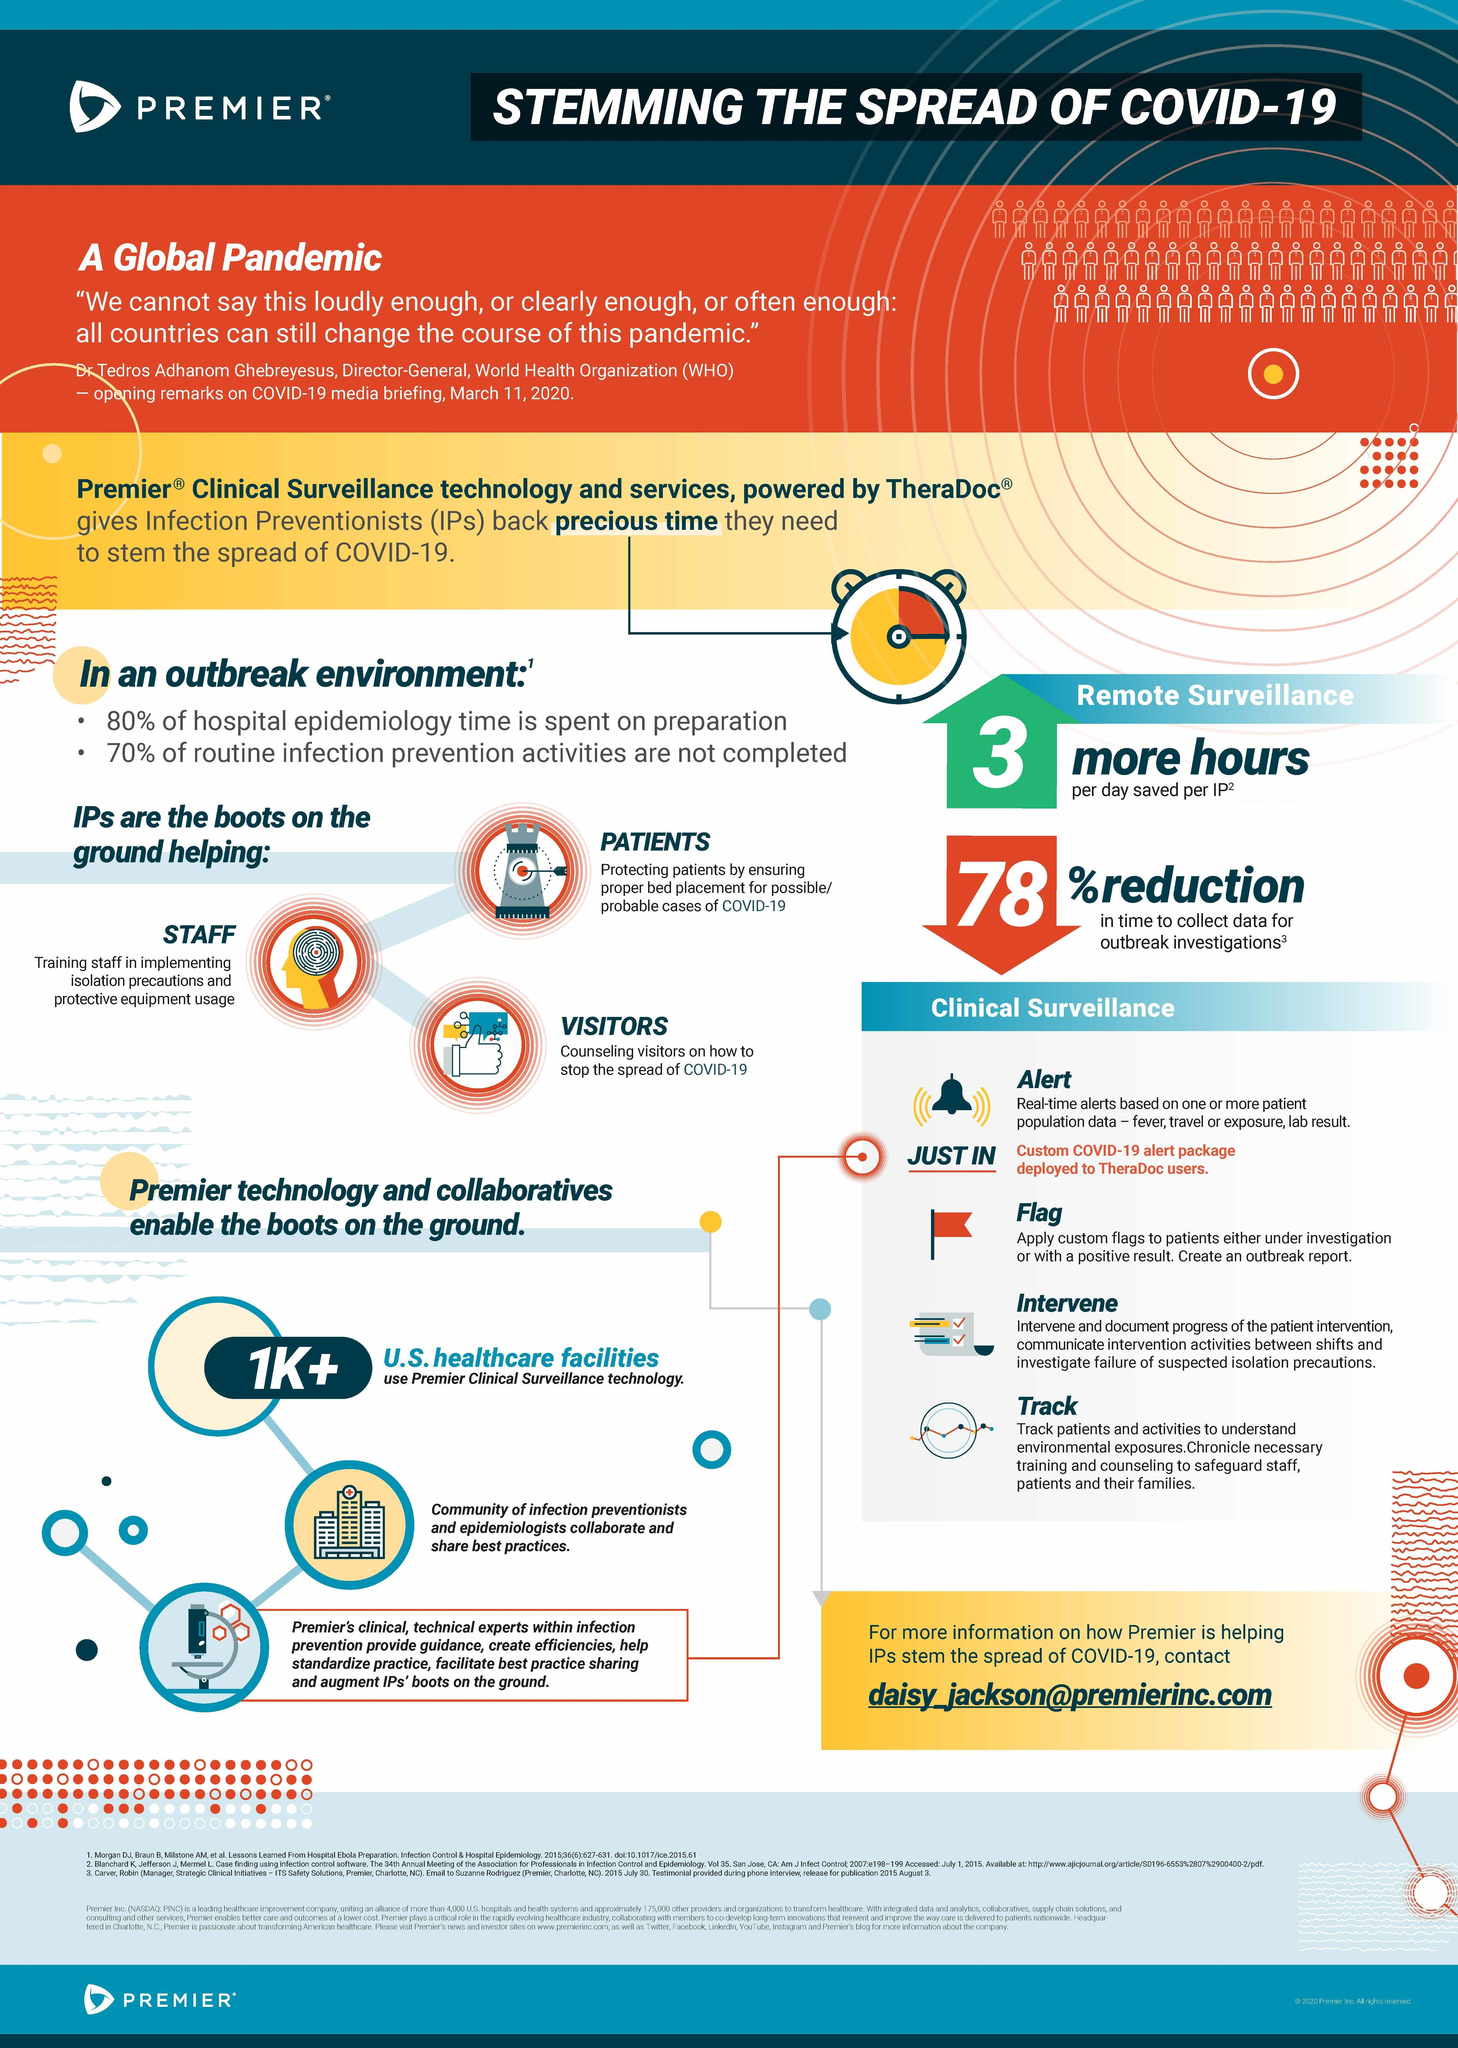Give some essential details in this illustration. Premier Clinical Surveillance Technology is currently used by over one thousand healthcare facilities in the United States. 